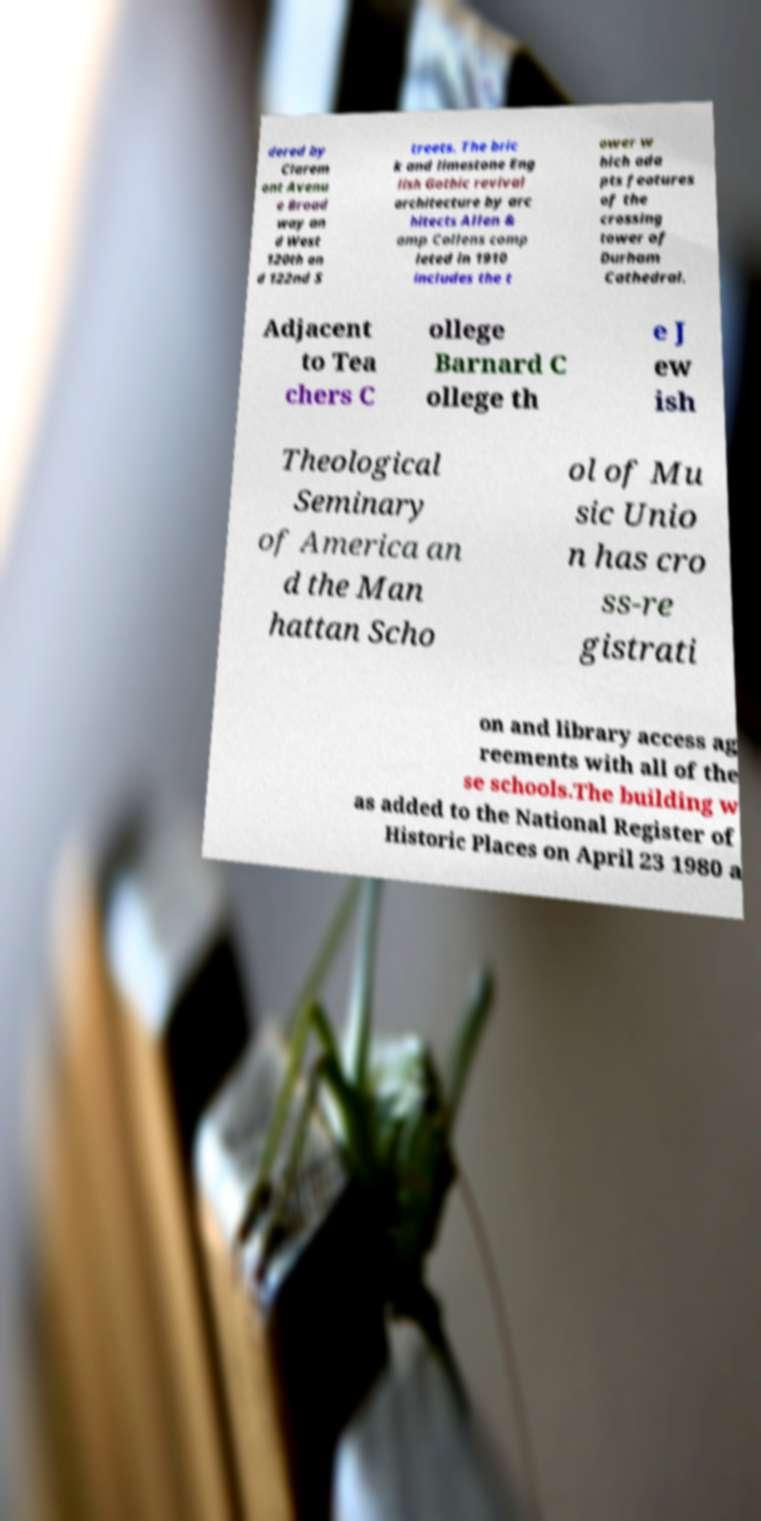Could you extract and type out the text from this image? dered by Clarem ont Avenu e Broad way an d West 120th an d 122nd S treets. The bric k and limestone Eng lish Gothic revival architecture by arc hitects Allen & amp Collens comp leted in 1910 includes the t ower w hich ada pts features of the crossing tower of Durham Cathedral. Adjacent to Tea chers C ollege Barnard C ollege th e J ew ish Theological Seminary of America an d the Man hattan Scho ol of Mu sic Unio n has cro ss-re gistrati on and library access ag reements with all of the se schools.The building w as added to the National Register of Historic Places on April 23 1980 a 